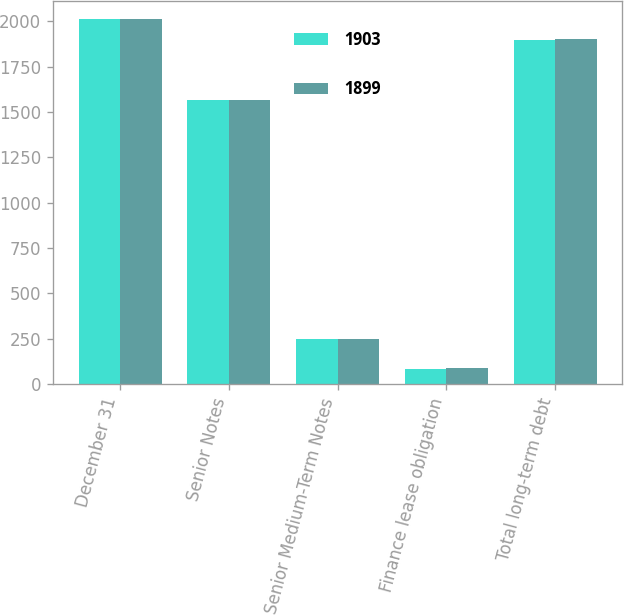Convert chart to OTSL. <chart><loc_0><loc_0><loc_500><loc_500><stacked_bar_chart><ecel><fcel>December 31<fcel>Senior Notes<fcel>Senior Medium-Term Notes<fcel>Finance lease obligation<fcel>Total long-term debt<nl><fcel>1903<fcel>2014<fcel>1567<fcel>249<fcel>83<fcel>1899<nl><fcel>1899<fcel>2013<fcel>1565<fcel>249<fcel>89<fcel>1903<nl></chart> 